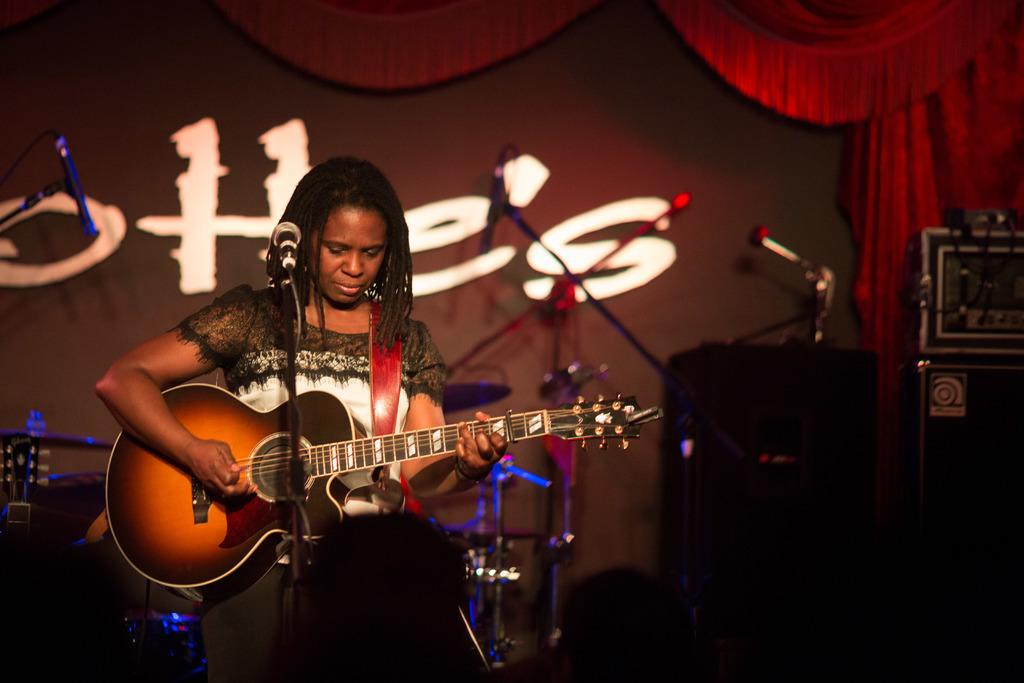What type of structure can be seen in the image? There is a wall in the image. What is hanging near the wall? There is a curtain in the image. What objects are related to music in the image? There are musical instruments in the image. Who is present in the image? There is a woman standing in the image. What is the woman holding? The woman is holding a guitar. What device is in front of the woman? There is a microphone in front of the woman. Where can the tomatoes be found in the image? There are no tomatoes present in the image. What type of treatment is being administered to the woman in the image? There is no treatment being administered to the woman in the image; she is simply holding a guitar and standing near a microphone. 